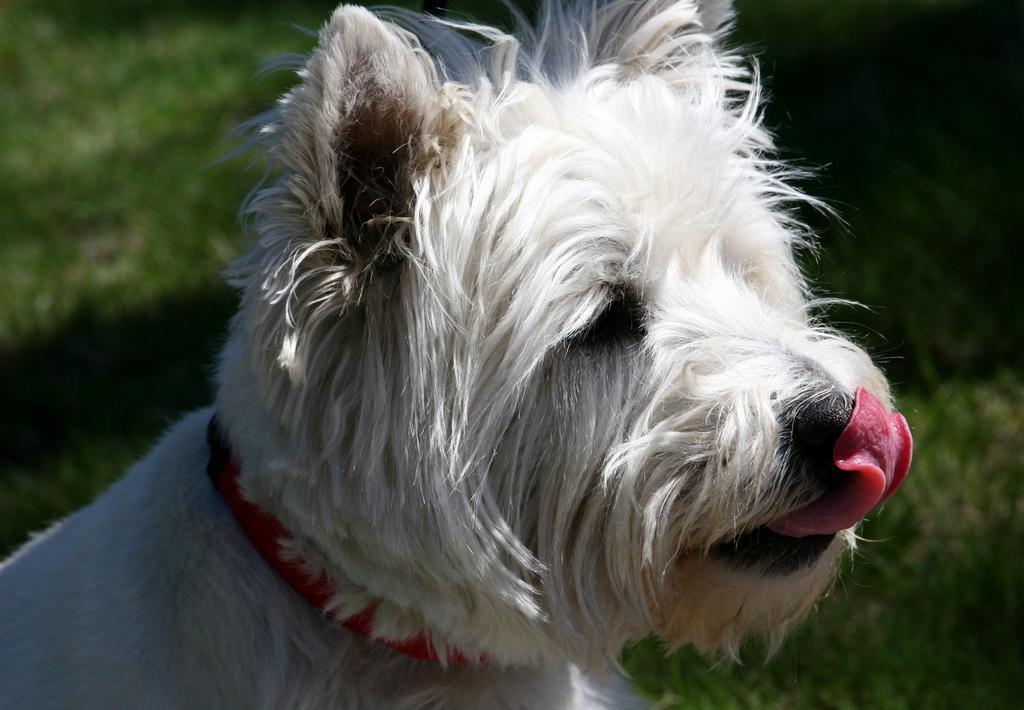Please provide a concise description of this image. In the center of the image there is a dog. In the background there is grass. 